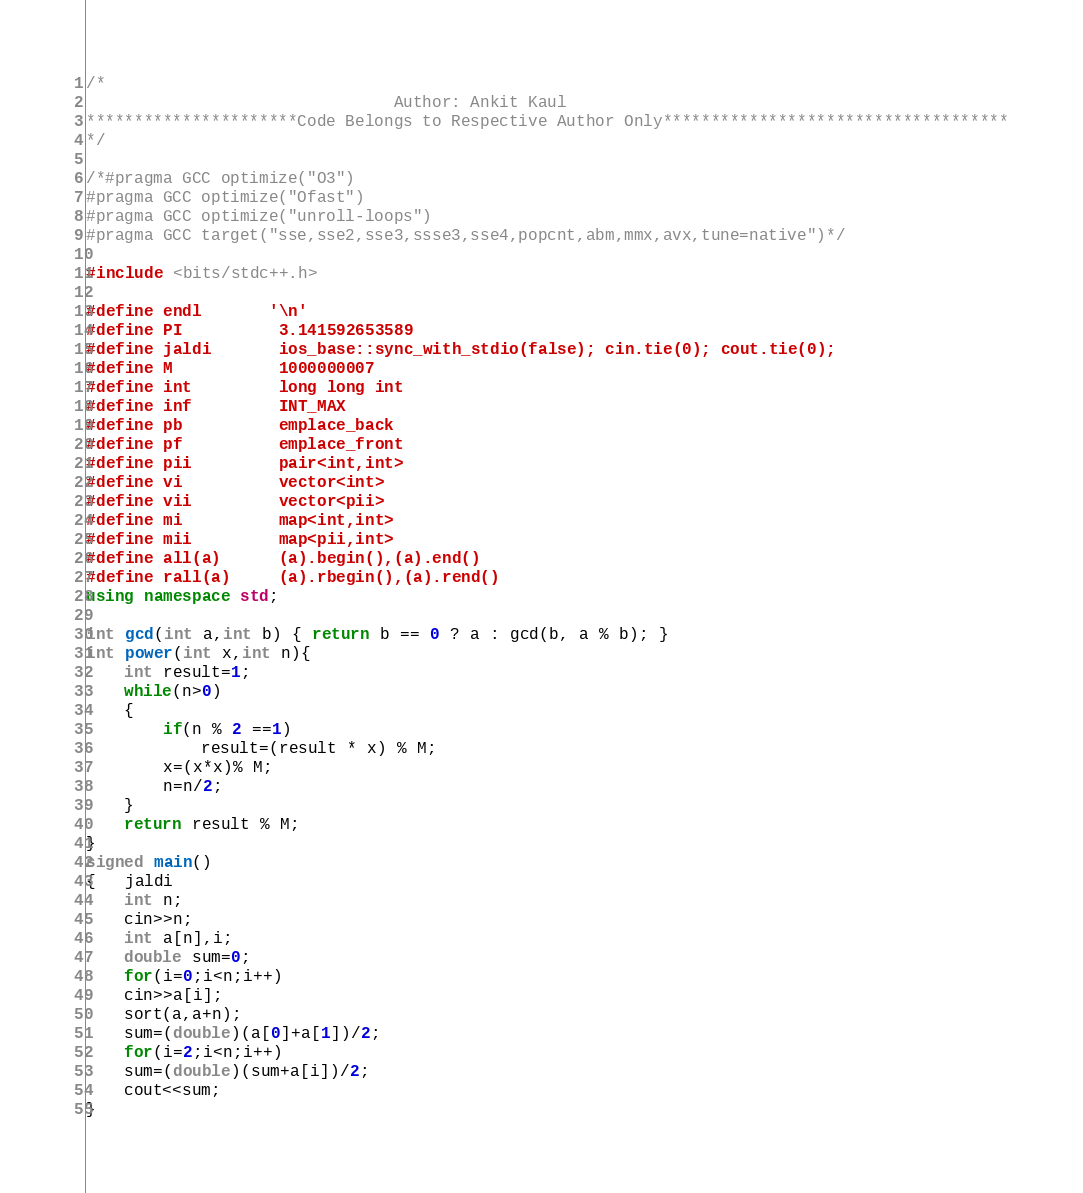Convert code to text. <code><loc_0><loc_0><loc_500><loc_500><_C++_>
/*
                                Author: Ankit Kaul
**********************Code Belongs to Respective Author Only************************************
*/
 
/*#pragma GCC optimize("O3")
#pragma GCC optimize("Ofast")
#pragma GCC optimize("unroll-loops")
#pragma GCC target("sse,sse2,sse3,ssse3,sse4,popcnt,abm,mmx,avx,tune=native")*/

#include <bits/stdc++.h>

#define endl       '\n'
#define PI          3.141592653589
#define jaldi       ios_base::sync_with_stdio(false); cin.tie(0); cout.tie(0);
#define M           1000000007
#define int         long long int
#define inf         INT_MAX
#define pb          emplace_back
#define pf          emplace_front
#define pii         pair<int,int>
#define vi          vector<int>
#define vii         vector<pii>
#define mi          map<int,int>
#define mii         map<pii,int>
#define all(a)      (a).begin(),(a).end()
#define rall(a)     (a).rbegin(),(a).rend()
using namespace std;
 
int gcd(int a,int b) { return b == 0 ? a : gcd(b, a % b); }
int power(int x,int n){
    int result=1;
    while(n>0)
    {
        if(n % 2 ==1)
            result=(result * x) % M;
        x=(x*x)% M;
        n=n/2;
    }
    return result % M;
}
signed main()
{   jaldi
	int n;
	cin>>n;
	int a[n],i;
	double sum=0;
	for(i=0;i<n;i++)
	cin>>a[i];
	sort(a,a+n);
	sum=(double)(a[0]+a[1])/2;
	for(i=2;i<n;i++)
	sum=(double)(sum+a[i])/2;		
	cout<<sum;
}</code> 